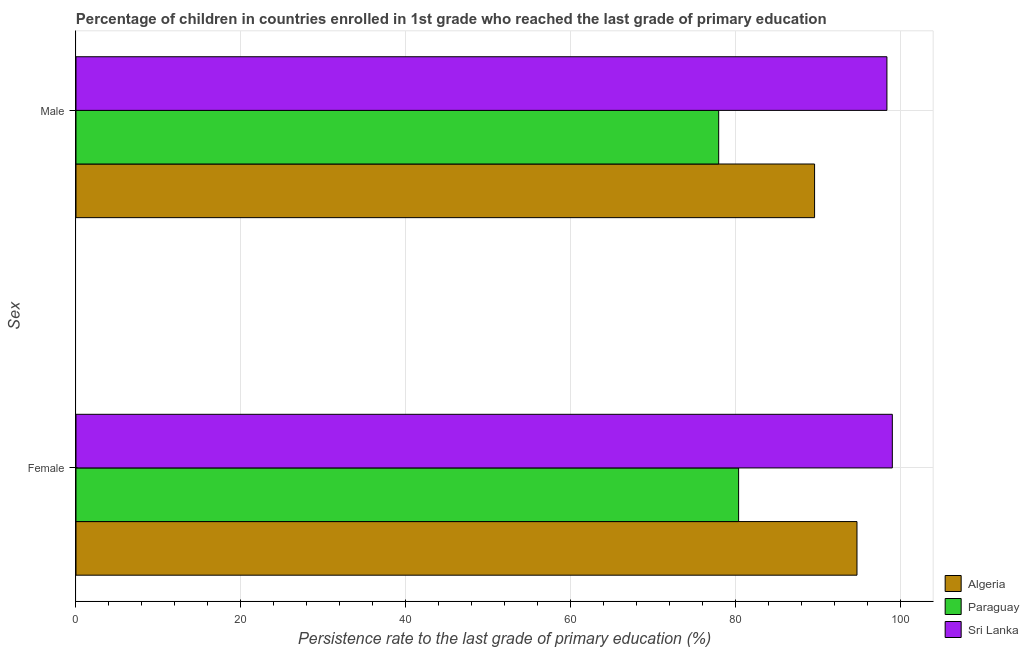How many different coloured bars are there?
Make the answer very short. 3. How many bars are there on the 2nd tick from the bottom?
Your answer should be compact. 3. What is the persistence rate of female students in Paraguay?
Give a very brief answer. 80.33. Across all countries, what is the maximum persistence rate of male students?
Provide a succinct answer. 98.31. Across all countries, what is the minimum persistence rate of female students?
Give a very brief answer. 80.33. In which country was the persistence rate of male students maximum?
Provide a short and direct response. Sri Lanka. In which country was the persistence rate of female students minimum?
Your response must be concise. Paraguay. What is the total persistence rate of female students in the graph?
Provide a succinct answer. 273.98. What is the difference between the persistence rate of female students in Sri Lanka and that in Algeria?
Your response must be concise. 4.28. What is the difference between the persistence rate of male students in Sri Lanka and the persistence rate of female students in Algeria?
Offer a very short reply. 3.63. What is the average persistence rate of female students per country?
Make the answer very short. 91.33. What is the difference between the persistence rate of female students and persistence rate of male students in Paraguay?
Your answer should be compact. 2.41. What is the ratio of the persistence rate of male students in Paraguay to that in Sri Lanka?
Ensure brevity in your answer.  0.79. What does the 1st bar from the top in Male represents?
Make the answer very short. Sri Lanka. What does the 1st bar from the bottom in Female represents?
Your answer should be very brief. Algeria. Are all the bars in the graph horizontal?
Offer a very short reply. Yes. How many countries are there in the graph?
Offer a terse response. 3. What is the difference between two consecutive major ticks on the X-axis?
Your answer should be compact. 20. How many legend labels are there?
Your answer should be very brief. 3. How are the legend labels stacked?
Offer a terse response. Vertical. What is the title of the graph?
Your answer should be compact. Percentage of children in countries enrolled in 1st grade who reached the last grade of primary education. What is the label or title of the X-axis?
Keep it short and to the point. Persistence rate to the last grade of primary education (%). What is the label or title of the Y-axis?
Give a very brief answer. Sex. What is the Persistence rate to the last grade of primary education (%) in Algeria in Female?
Give a very brief answer. 94.68. What is the Persistence rate to the last grade of primary education (%) in Paraguay in Female?
Offer a very short reply. 80.33. What is the Persistence rate to the last grade of primary education (%) in Sri Lanka in Female?
Your answer should be compact. 98.97. What is the Persistence rate to the last grade of primary education (%) of Algeria in Male?
Ensure brevity in your answer.  89.54. What is the Persistence rate to the last grade of primary education (%) of Paraguay in Male?
Your answer should be compact. 77.92. What is the Persistence rate to the last grade of primary education (%) of Sri Lanka in Male?
Your response must be concise. 98.31. Across all Sex, what is the maximum Persistence rate to the last grade of primary education (%) in Algeria?
Keep it short and to the point. 94.68. Across all Sex, what is the maximum Persistence rate to the last grade of primary education (%) in Paraguay?
Provide a short and direct response. 80.33. Across all Sex, what is the maximum Persistence rate to the last grade of primary education (%) of Sri Lanka?
Keep it short and to the point. 98.97. Across all Sex, what is the minimum Persistence rate to the last grade of primary education (%) in Algeria?
Your answer should be very brief. 89.54. Across all Sex, what is the minimum Persistence rate to the last grade of primary education (%) in Paraguay?
Provide a short and direct response. 77.92. Across all Sex, what is the minimum Persistence rate to the last grade of primary education (%) in Sri Lanka?
Offer a terse response. 98.31. What is the total Persistence rate to the last grade of primary education (%) of Algeria in the graph?
Keep it short and to the point. 184.22. What is the total Persistence rate to the last grade of primary education (%) in Paraguay in the graph?
Provide a succinct answer. 158.25. What is the total Persistence rate to the last grade of primary education (%) in Sri Lanka in the graph?
Offer a terse response. 197.28. What is the difference between the Persistence rate to the last grade of primary education (%) of Algeria in Female and that in Male?
Your answer should be very brief. 5.14. What is the difference between the Persistence rate to the last grade of primary education (%) in Paraguay in Female and that in Male?
Make the answer very short. 2.41. What is the difference between the Persistence rate to the last grade of primary education (%) in Sri Lanka in Female and that in Male?
Give a very brief answer. 0.66. What is the difference between the Persistence rate to the last grade of primary education (%) in Algeria in Female and the Persistence rate to the last grade of primary education (%) in Paraguay in Male?
Your answer should be compact. 16.77. What is the difference between the Persistence rate to the last grade of primary education (%) of Algeria in Female and the Persistence rate to the last grade of primary education (%) of Sri Lanka in Male?
Keep it short and to the point. -3.63. What is the difference between the Persistence rate to the last grade of primary education (%) in Paraguay in Female and the Persistence rate to the last grade of primary education (%) in Sri Lanka in Male?
Your response must be concise. -17.98. What is the average Persistence rate to the last grade of primary education (%) in Algeria per Sex?
Provide a succinct answer. 92.11. What is the average Persistence rate to the last grade of primary education (%) of Paraguay per Sex?
Offer a very short reply. 79.12. What is the average Persistence rate to the last grade of primary education (%) in Sri Lanka per Sex?
Ensure brevity in your answer.  98.64. What is the difference between the Persistence rate to the last grade of primary education (%) of Algeria and Persistence rate to the last grade of primary education (%) of Paraguay in Female?
Provide a succinct answer. 14.35. What is the difference between the Persistence rate to the last grade of primary education (%) of Algeria and Persistence rate to the last grade of primary education (%) of Sri Lanka in Female?
Offer a terse response. -4.28. What is the difference between the Persistence rate to the last grade of primary education (%) of Paraguay and Persistence rate to the last grade of primary education (%) of Sri Lanka in Female?
Keep it short and to the point. -18.64. What is the difference between the Persistence rate to the last grade of primary education (%) of Algeria and Persistence rate to the last grade of primary education (%) of Paraguay in Male?
Provide a succinct answer. 11.62. What is the difference between the Persistence rate to the last grade of primary education (%) of Algeria and Persistence rate to the last grade of primary education (%) of Sri Lanka in Male?
Your answer should be compact. -8.77. What is the difference between the Persistence rate to the last grade of primary education (%) in Paraguay and Persistence rate to the last grade of primary education (%) in Sri Lanka in Male?
Your answer should be compact. -20.39. What is the ratio of the Persistence rate to the last grade of primary education (%) in Algeria in Female to that in Male?
Give a very brief answer. 1.06. What is the ratio of the Persistence rate to the last grade of primary education (%) in Paraguay in Female to that in Male?
Offer a terse response. 1.03. What is the difference between the highest and the second highest Persistence rate to the last grade of primary education (%) in Algeria?
Provide a short and direct response. 5.14. What is the difference between the highest and the second highest Persistence rate to the last grade of primary education (%) in Paraguay?
Your response must be concise. 2.41. What is the difference between the highest and the second highest Persistence rate to the last grade of primary education (%) of Sri Lanka?
Keep it short and to the point. 0.66. What is the difference between the highest and the lowest Persistence rate to the last grade of primary education (%) of Algeria?
Your response must be concise. 5.14. What is the difference between the highest and the lowest Persistence rate to the last grade of primary education (%) of Paraguay?
Your response must be concise. 2.41. What is the difference between the highest and the lowest Persistence rate to the last grade of primary education (%) of Sri Lanka?
Your answer should be compact. 0.66. 